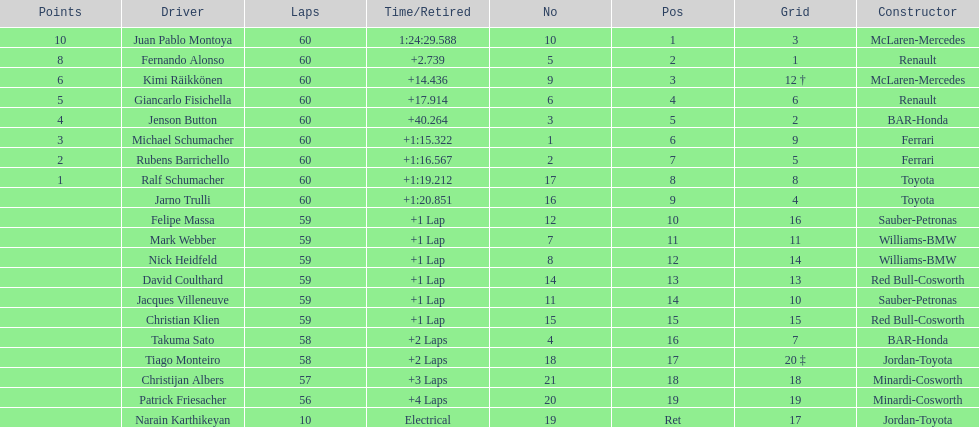After 8th position, how many points does a driver receive? 0. 